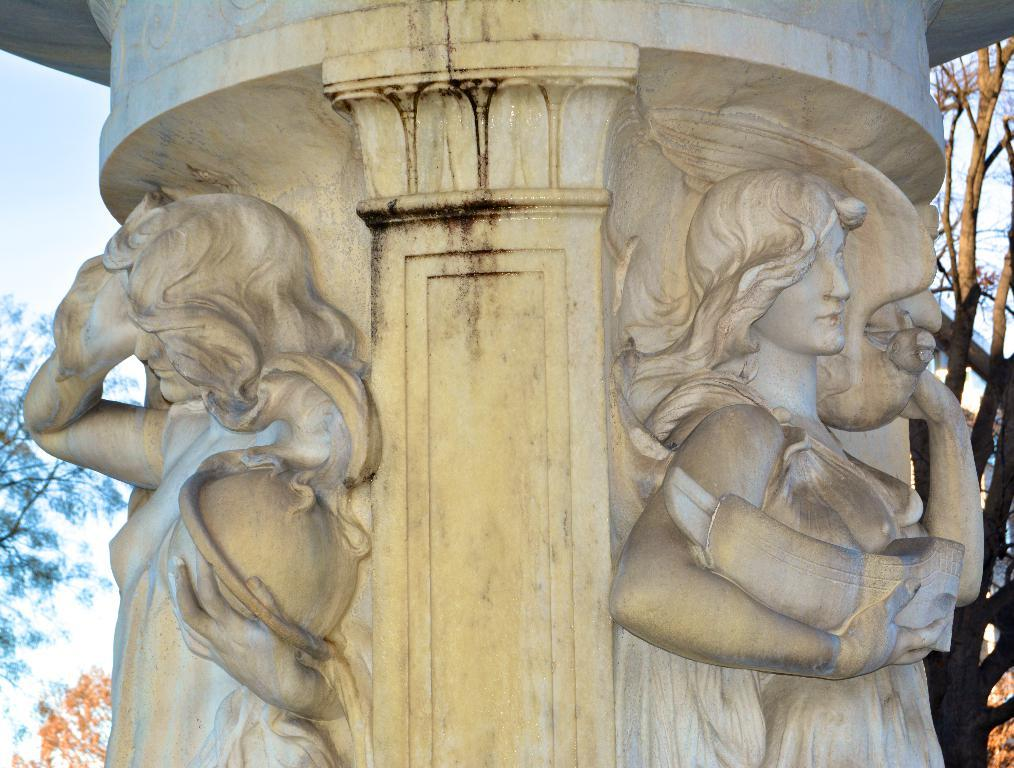What is the main structure visible in the image? There is a pillar in the image. What decorative elements are present on the pillar? There are sculptures on the pillar. What type of natural environment is visible in the background of the image? There are trees in the background of the image. What is visible in the sky in the background of the image? The sky is visible in the background of the image. What type of pipe is visible in the image? There is no pipe present in the image. What type of furniture can be seen in the image? There is no furniture present in the image. 